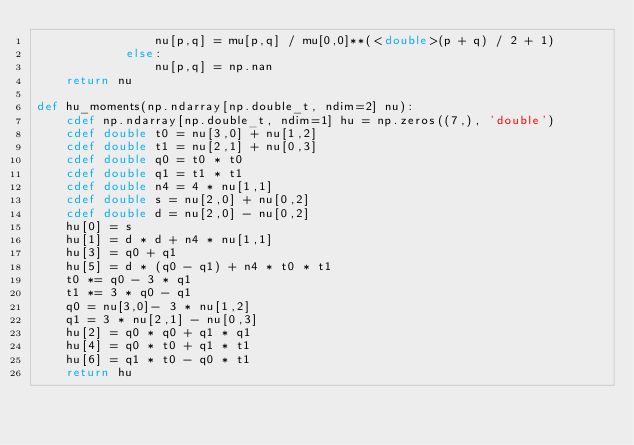Convert code to text. <code><loc_0><loc_0><loc_500><loc_500><_Cython_>                nu[p,q] = mu[p,q] / mu[0,0]**(<double>(p + q) / 2 + 1)
            else:
                nu[p,q] = np.nan
    return nu

def hu_moments(np.ndarray[np.double_t, ndim=2] nu):
    cdef np.ndarray[np.double_t, ndim=1] hu = np.zeros((7,), 'double')
    cdef double t0 = nu[3,0] + nu[1,2]
    cdef double t1 = nu[2,1] + nu[0,3]
    cdef double q0 = t0 * t0
    cdef double q1 = t1 * t1
    cdef double n4 = 4 * nu[1,1]
    cdef double s = nu[2,0] + nu[0,2]
    cdef double d = nu[2,0] - nu[0,2]
    hu[0] = s
    hu[1] = d * d + n4 * nu[1,1]
    hu[3] = q0 + q1
    hu[5] = d * (q0 - q1) + n4 * t0 * t1
    t0 *= q0 - 3 * q1
    t1 *= 3 * q0 - q1
    q0 = nu[3,0]- 3 * nu[1,2]
    q1 = 3 * nu[2,1] - nu[0,3]
    hu[2] = q0 * q0 + q1 * q1
    hu[4] = q0 * t0 + q1 * t1
    hu[6] = q1 * t0 - q0 * t1
    return hu
</code> 